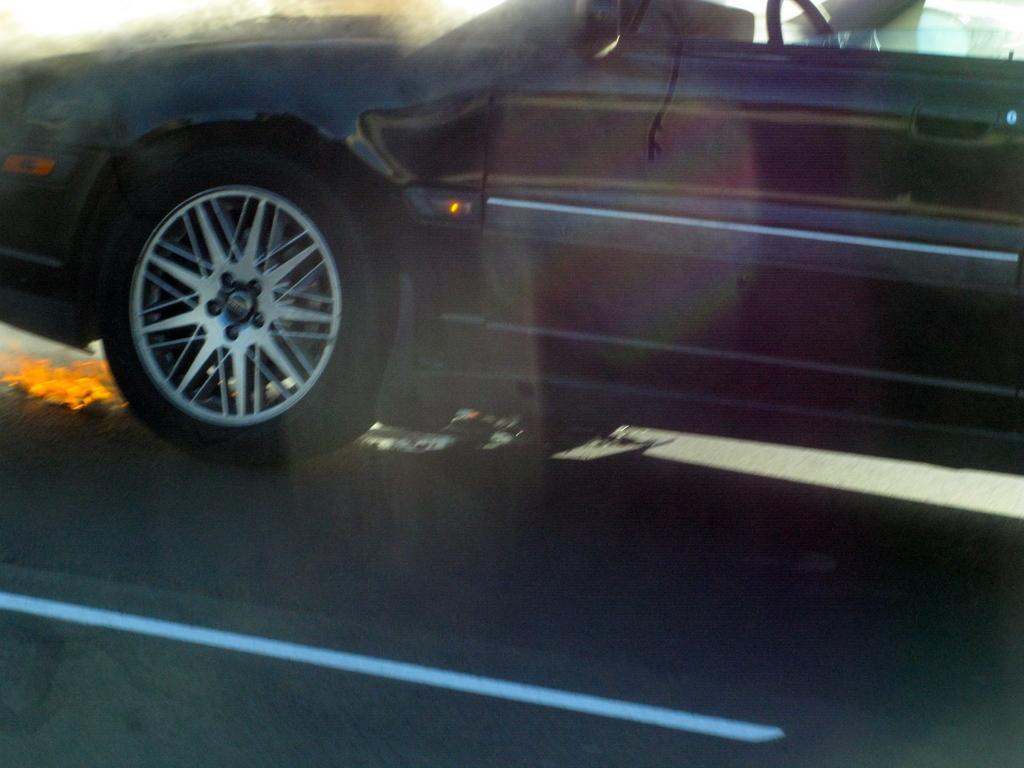How would you summarize this image in a sentence or two? A black color car is moving on this road. 